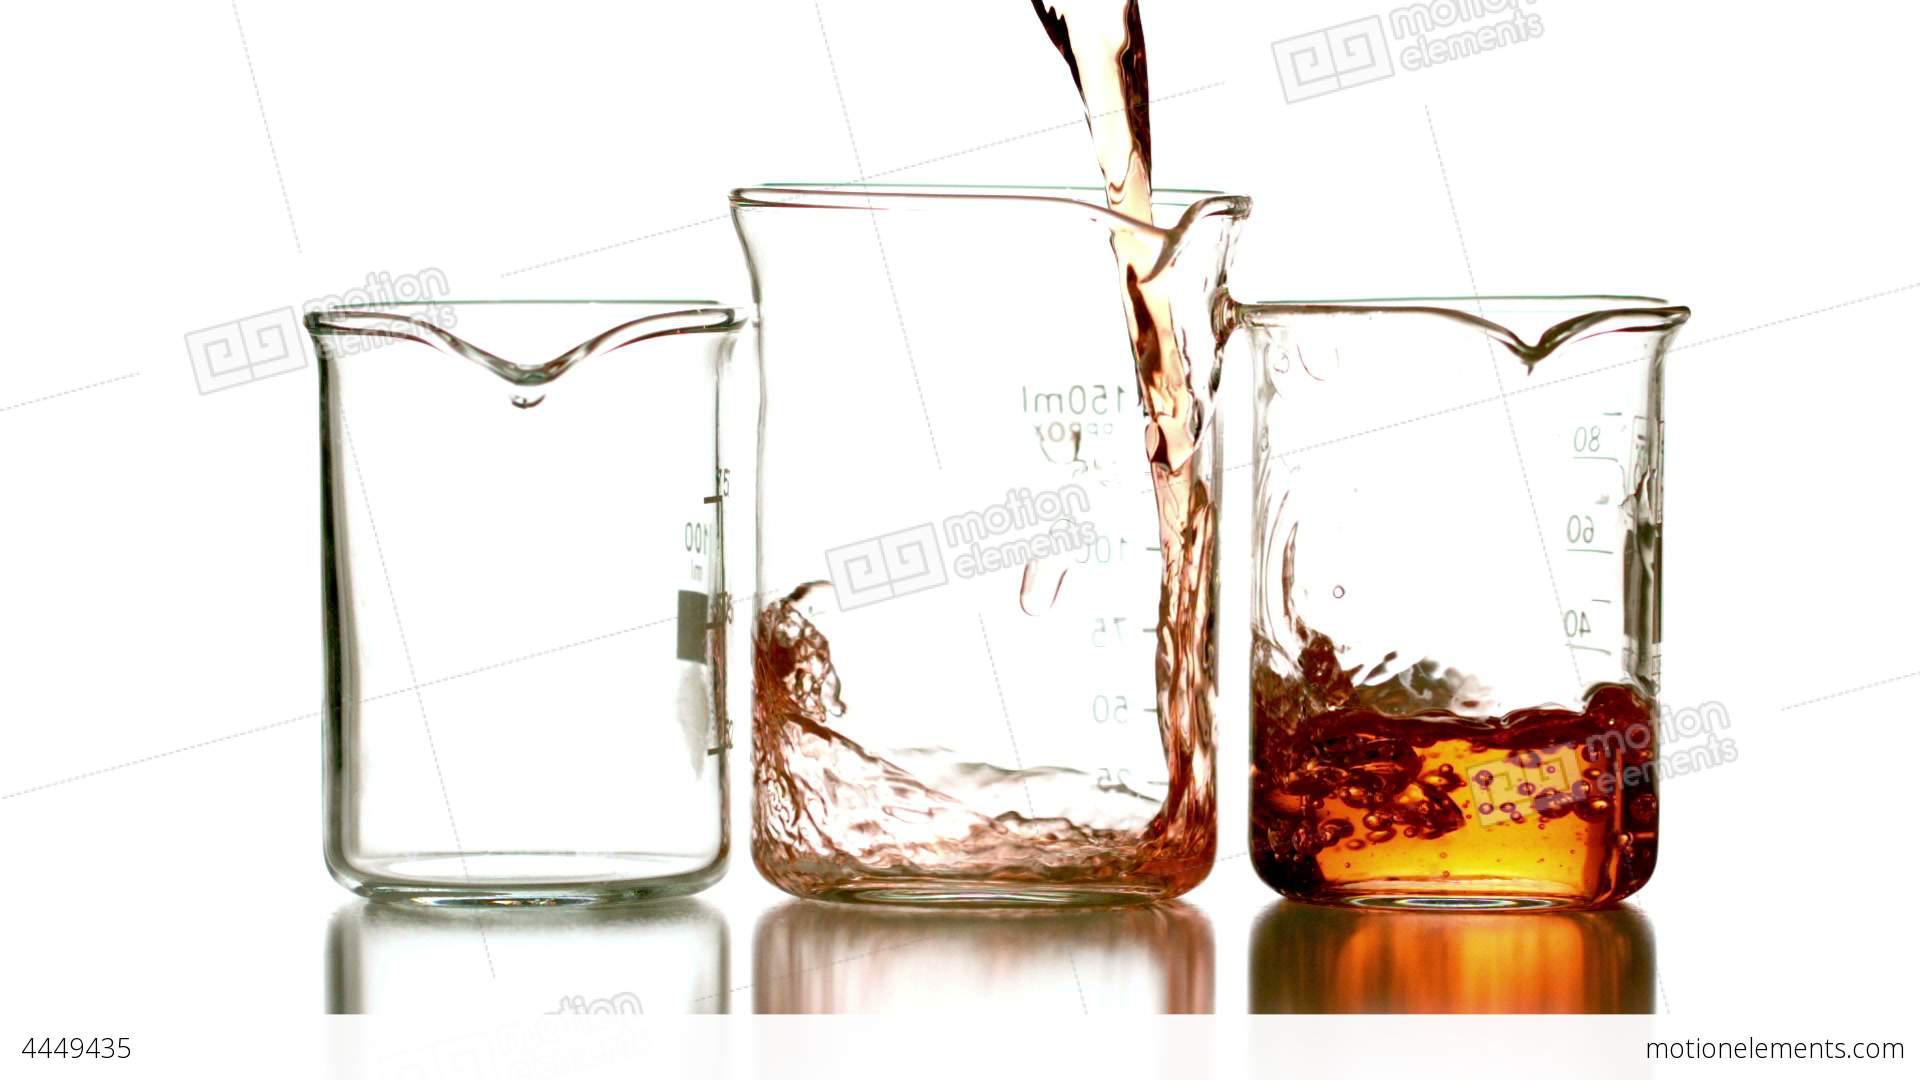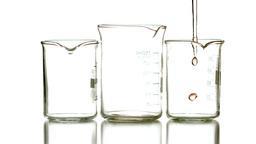The first image is the image on the left, the second image is the image on the right. Assess this claim about the two images: "One image shows colored liquid pouring into a glass, and the image contains just one glass.". Correct or not? Answer yes or no. No. The first image is the image on the left, the second image is the image on the right. Given the left and right images, does the statement "There are substances in three containers in the image on the left." hold true? Answer yes or no. No. 